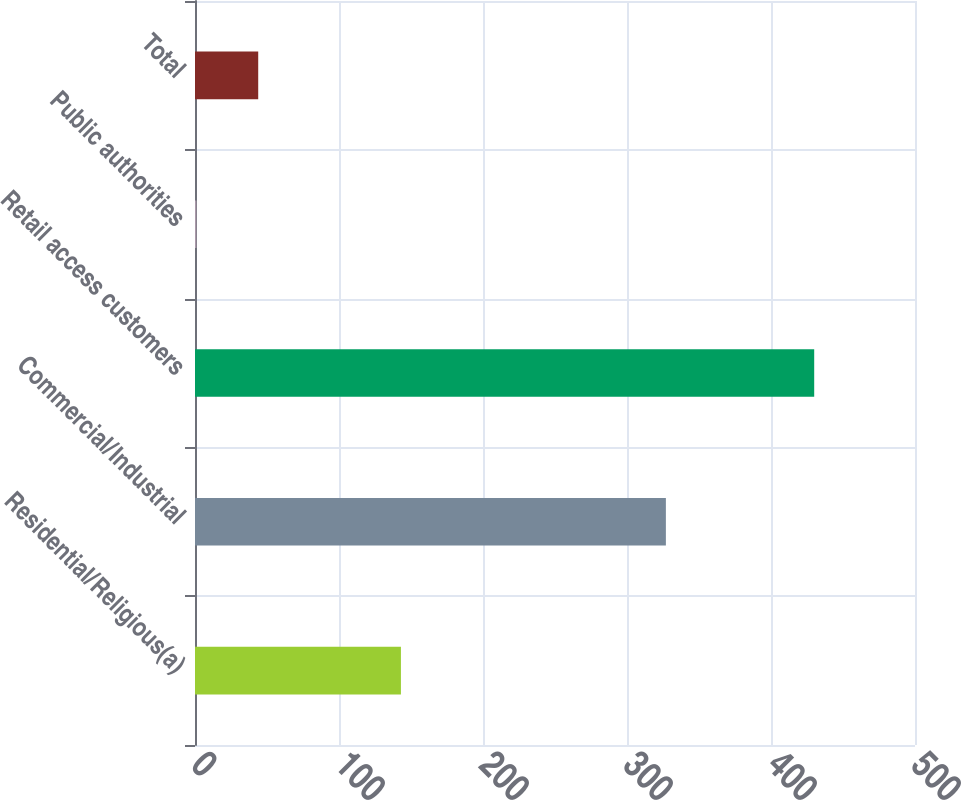Convert chart. <chart><loc_0><loc_0><loc_500><loc_500><bar_chart><fcel>Residential/Religious(a)<fcel>Commercial/Industrial<fcel>Retail access customers<fcel>Public authorities<fcel>Total<nl><fcel>143<fcel>327<fcel>430<fcel>1<fcel>43.9<nl></chart> 